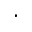Convert formula to latex. <formula><loc_0><loc_0><loc_500><loc_500>\cdot</formula> 